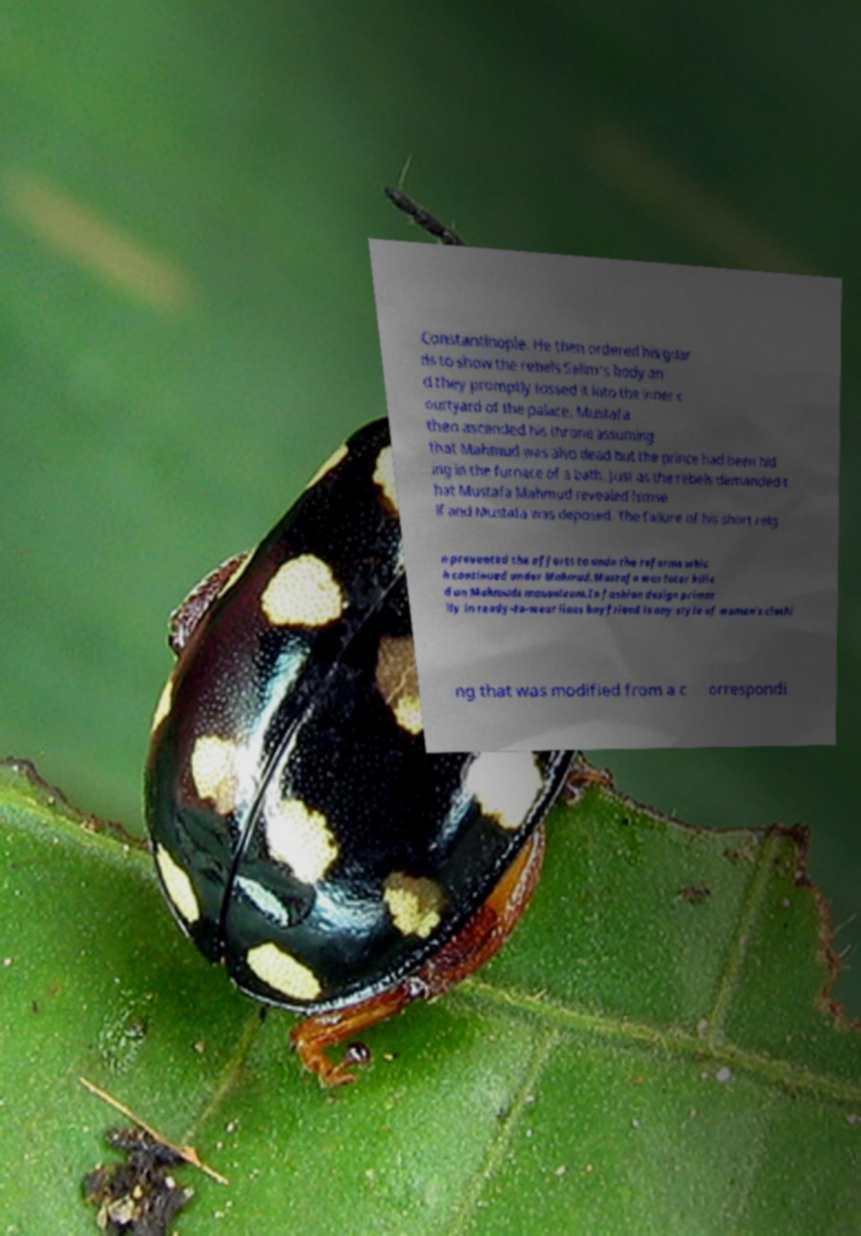For documentation purposes, I need the text within this image transcribed. Could you provide that? Constantinople. He then ordered his guar ds to show the rebels Selim's body an d they promptly tossed it into the inner c ourtyard of the palace. Mustafa then ascended his throne assuming that Mahmud was also dead but the prince had been hid ing in the furnace of a bath. Just as the rebels demanded t hat Mustafa Mahmud revealed himse lf and Mustafa was deposed. The failure of his short reig n prevented the efforts to undo the reforms whic h continued under Mahmud.Mustafa was later kille d on Mahmuds mausoleum.In fashion design primar ily in ready-to-wear lines boyfriend is any style of women's clothi ng that was modified from a c orrespondi 